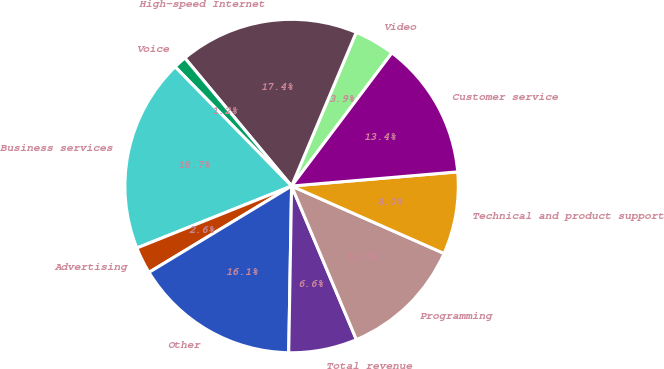<chart> <loc_0><loc_0><loc_500><loc_500><pie_chart><fcel>Video<fcel>High-speed Internet<fcel>Voice<fcel>Business services<fcel>Advertising<fcel>Other<fcel>Total revenue<fcel>Programming<fcel>Technical and product support<fcel>Customer service<nl><fcel>3.94%<fcel>17.4%<fcel>1.25%<fcel>18.75%<fcel>2.6%<fcel>16.06%<fcel>6.63%<fcel>12.02%<fcel>7.98%<fcel>13.37%<nl></chart> 